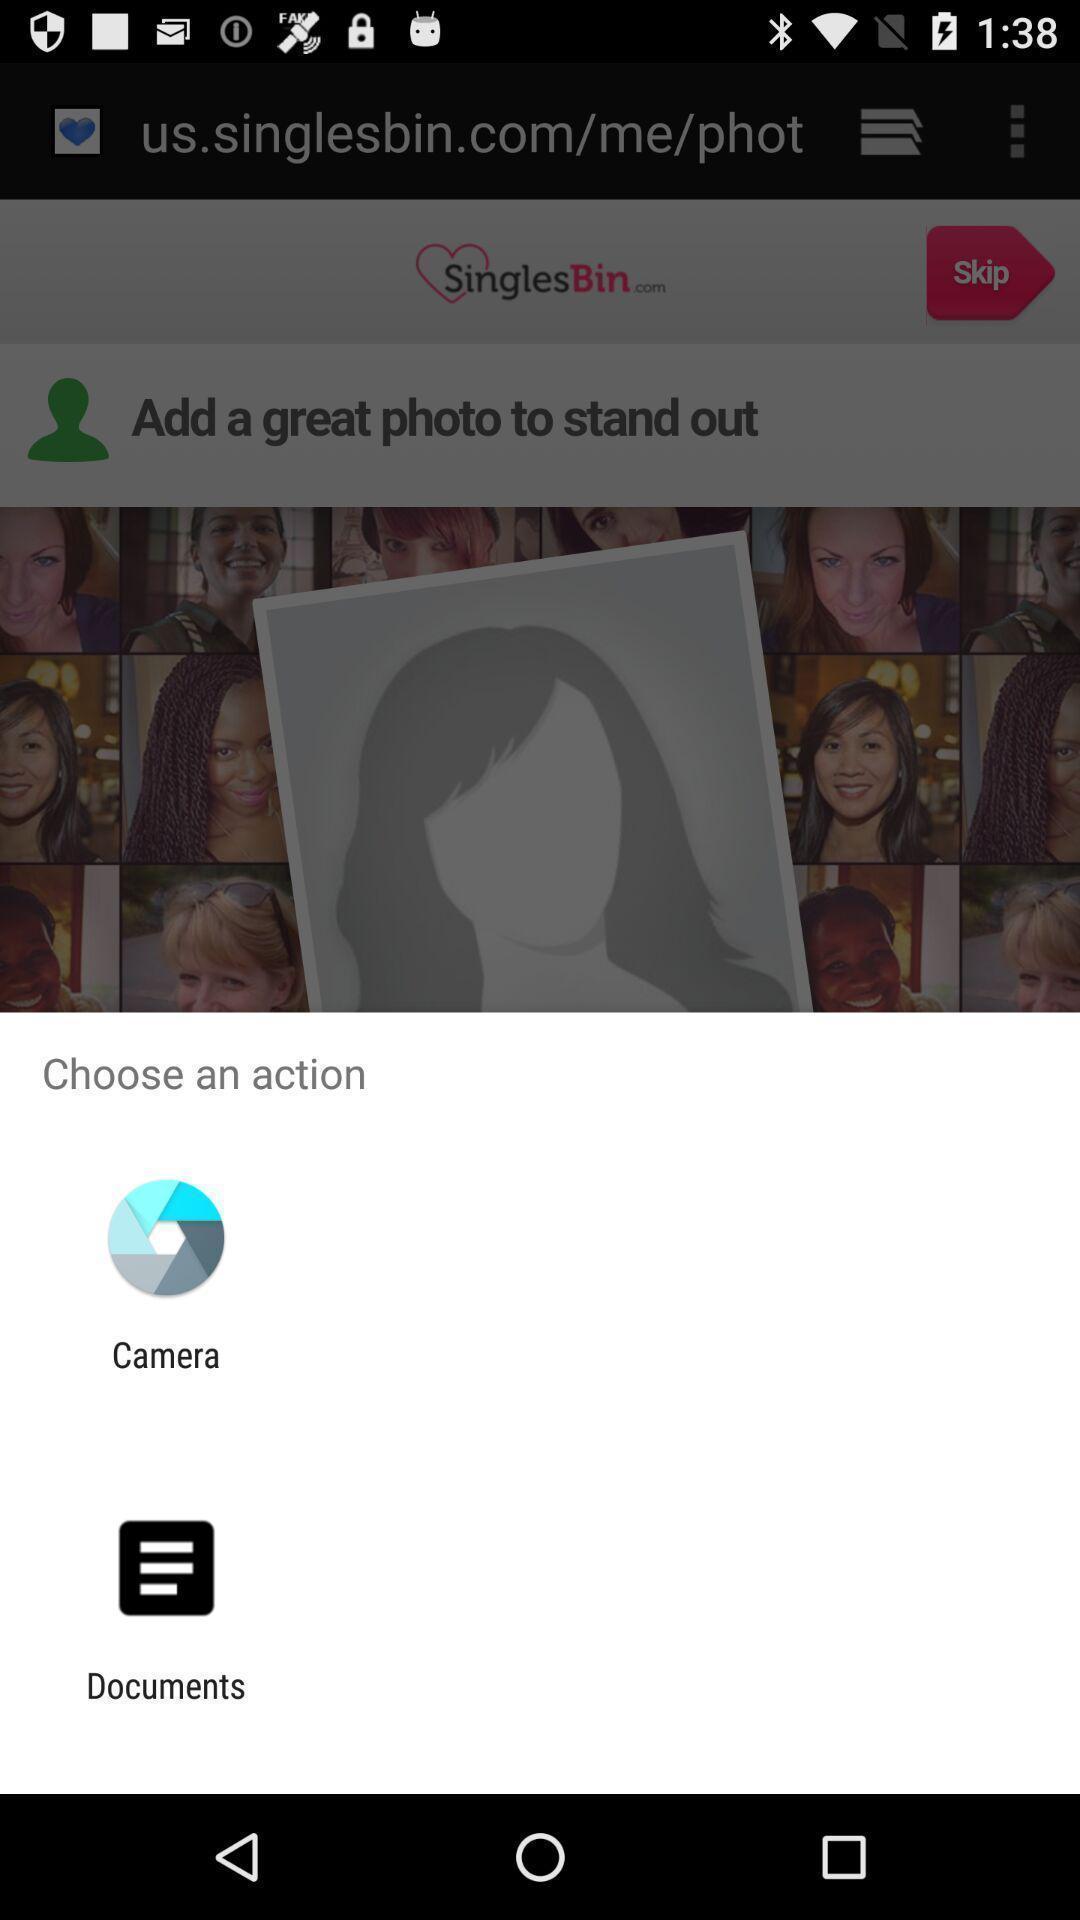Provide a textual representation of this image. Pop-up showing options to choose. 